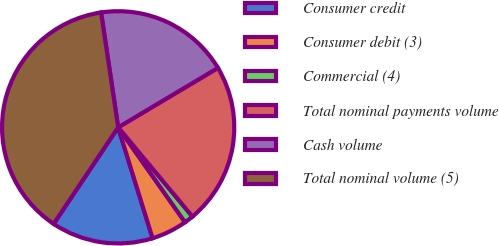<chart> <loc_0><loc_0><loc_500><loc_500><pie_chart><fcel>Consumer credit<fcel>Consumer debit (3)<fcel>Commercial (4)<fcel>Total nominal payments volume<fcel>Cash volume<fcel>Total nominal volume (5)<nl><fcel>14.17%<fcel>4.98%<fcel>1.28%<fcel>22.5%<fcel>18.8%<fcel>38.27%<nl></chart> 